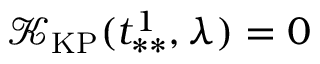<formula> <loc_0><loc_0><loc_500><loc_500>\mathcal { K } _ { K P } ( t _ { * * } ^ { 1 } , \lambda ) = 0</formula> 